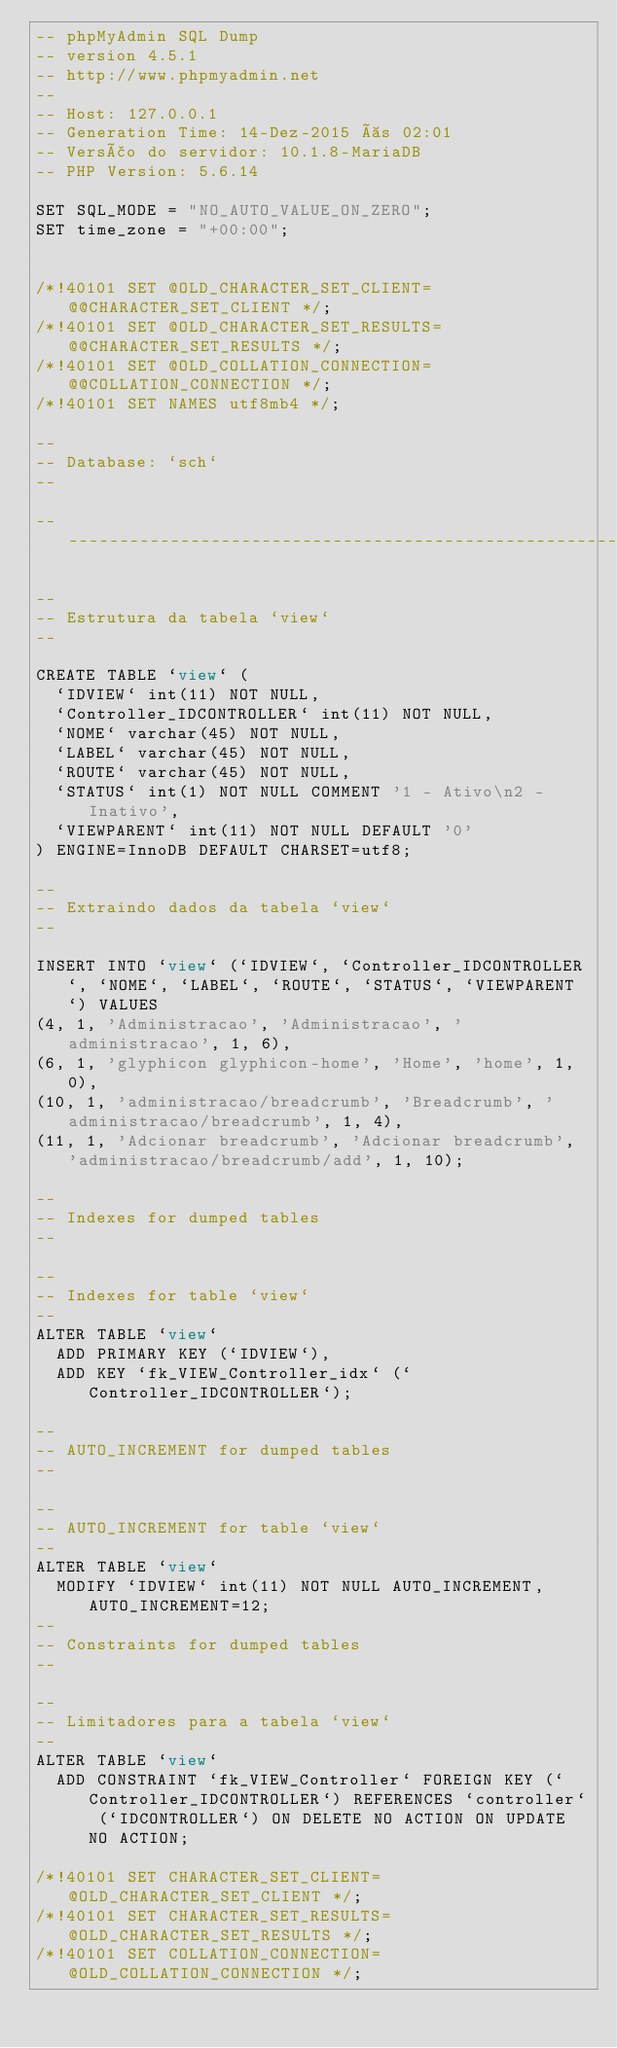<code> <loc_0><loc_0><loc_500><loc_500><_SQL_>-- phpMyAdmin SQL Dump
-- version 4.5.1
-- http://www.phpmyadmin.net
--
-- Host: 127.0.0.1
-- Generation Time: 14-Dez-2015 às 02:01
-- Versão do servidor: 10.1.8-MariaDB
-- PHP Version: 5.6.14

SET SQL_MODE = "NO_AUTO_VALUE_ON_ZERO";
SET time_zone = "+00:00";


/*!40101 SET @OLD_CHARACTER_SET_CLIENT=@@CHARACTER_SET_CLIENT */;
/*!40101 SET @OLD_CHARACTER_SET_RESULTS=@@CHARACTER_SET_RESULTS */;
/*!40101 SET @OLD_COLLATION_CONNECTION=@@COLLATION_CONNECTION */;
/*!40101 SET NAMES utf8mb4 */;

--
-- Database: `sch`
--

-- --------------------------------------------------------

--
-- Estrutura da tabela `view`
--

CREATE TABLE `view` (
  `IDVIEW` int(11) NOT NULL,
  `Controller_IDCONTROLLER` int(11) NOT NULL,
  `NOME` varchar(45) NOT NULL,
  `LABEL` varchar(45) NOT NULL,
  `ROUTE` varchar(45) NOT NULL,
  `STATUS` int(1) NOT NULL COMMENT '1 - Ativo\n2 - Inativo',
  `VIEWPARENT` int(11) NOT NULL DEFAULT '0'
) ENGINE=InnoDB DEFAULT CHARSET=utf8;

--
-- Extraindo dados da tabela `view`
--

INSERT INTO `view` (`IDVIEW`, `Controller_IDCONTROLLER`, `NOME`, `LABEL`, `ROUTE`, `STATUS`, `VIEWPARENT`) VALUES
(4, 1, 'Administracao', 'Administracao', 'administracao', 1, 6),
(6, 1, 'glyphicon glyphicon-home', 'Home', 'home', 1, 0),
(10, 1, 'administracao/breadcrumb', 'Breadcrumb', 'administracao/breadcrumb', 1, 4),
(11, 1, 'Adcionar breadcrumb', 'Adcionar breadcrumb', 'administracao/breadcrumb/add', 1, 10);

--
-- Indexes for dumped tables
--

--
-- Indexes for table `view`
--
ALTER TABLE `view`
  ADD PRIMARY KEY (`IDVIEW`),
  ADD KEY `fk_VIEW_Controller_idx` (`Controller_IDCONTROLLER`);

--
-- AUTO_INCREMENT for dumped tables
--

--
-- AUTO_INCREMENT for table `view`
--
ALTER TABLE `view`
  MODIFY `IDVIEW` int(11) NOT NULL AUTO_INCREMENT, AUTO_INCREMENT=12;
--
-- Constraints for dumped tables
--

--
-- Limitadores para a tabela `view`
--
ALTER TABLE `view`
  ADD CONSTRAINT `fk_VIEW_Controller` FOREIGN KEY (`Controller_IDCONTROLLER`) REFERENCES `controller` (`IDCONTROLLER`) ON DELETE NO ACTION ON UPDATE NO ACTION;

/*!40101 SET CHARACTER_SET_CLIENT=@OLD_CHARACTER_SET_CLIENT */;
/*!40101 SET CHARACTER_SET_RESULTS=@OLD_CHARACTER_SET_RESULTS */;
/*!40101 SET COLLATION_CONNECTION=@OLD_COLLATION_CONNECTION */;
</code> 